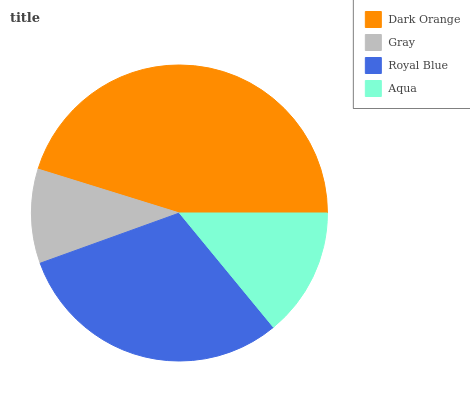Is Gray the minimum?
Answer yes or no. Yes. Is Dark Orange the maximum?
Answer yes or no. Yes. Is Royal Blue the minimum?
Answer yes or no. No. Is Royal Blue the maximum?
Answer yes or no. No. Is Royal Blue greater than Gray?
Answer yes or no. Yes. Is Gray less than Royal Blue?
Answer yes or no. Yes. Is Gray greater than Royal Blue?
Answer yes or no. No. Is Royal Blue less than Gray?
Answer yes or no. No. Is Royal Blue the high median?
Answer yes or no. Yes. Is Aqua the low median?
Answer yes or no. Yes. Is Aqua the high median?
Answer yes or no. No. Is Dark Orange the low median?
Answer yes or no. No. 